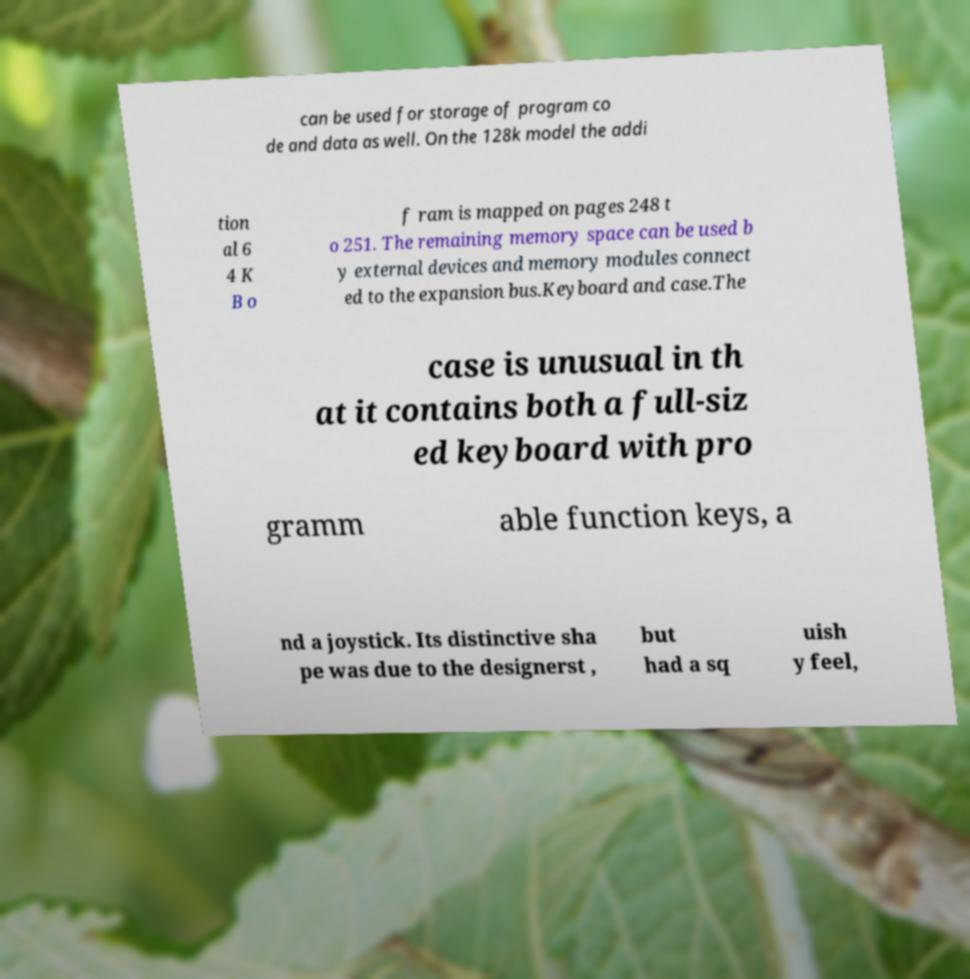Please read and relay the text visible in this image. What does it say? can be used for storage of program co de and data as well. On the 128k model the addi tion al 6 4 K B o f ram is mapped on pages 248 t o 251. The remaining memory space can be used b y external devices and memory modules connect ed to the expansion bus.Keyboard and case.The case is unusual in th at it contains both a full-siz ed keyboard with pro gramm able function keys, a nd a joystick. Its distinctive sha pe was due to the designerst , but had a sq uish y feel, 